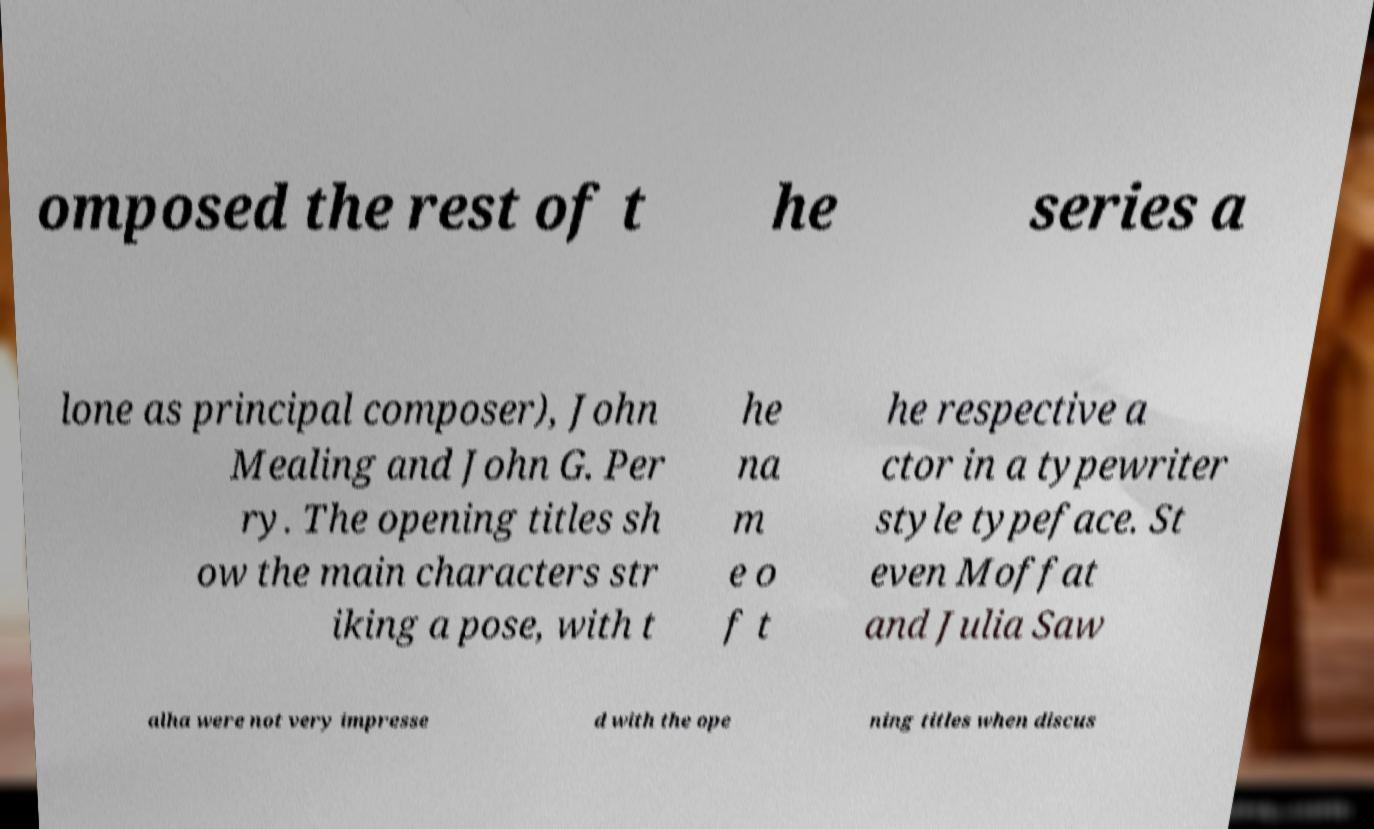Please read and relay the text visible in this image. What does it say? omposed the rest of t he series a lone as principal composer), John Mealing and John G. Per ry. The opening titles sh ow the main characters str iking a pose, with t he na m e o f t he respective a ctor in a typewriter style typeface. St even Moffat and Julia Saw alha were not very impresse d with the ope ning titles when discus 